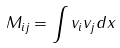<formula> <loc_0><loc_0><loc_500><loc_500>M _ { i j } = \int v _ { i } v _ { j } d x</formula> 